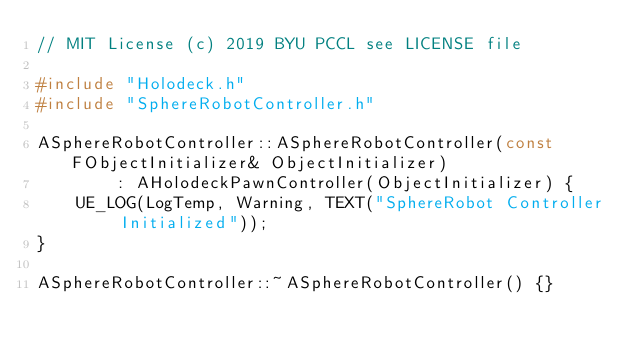<code> <loc_0><loc_0><loc_500><loc_500><_C++_>// MIT License (c) 2019 BYU PCCL see LICENSE file

#include "Holodeck.h"
#include "SphereRobotController.h"

ASphereRobotController::ASphereRobotController(const FObjectInitializer& ObjectInitializer)
		: AHolodeckPawnController(ObjectInitializer) {
	UE_LOG(LogTemp, Warning, TEXT("SphereRobot Controller Initialized"));
}

ASphereRobotController::~ASphereRobotController() {}
</code> 